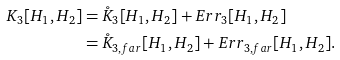Convert formula to latex. <formula><loc_0><loc_0><loc_500><loc_500>K _ { 3 } [ H _ { 1 } , H _ { 2 } ] & = \mathring { K } _ { 3 } [ H _ { 1 } , H _ { 2 } ] + E r r _ { 3 } [ H _ { 1 } , H _ { 2 } ] \\ & = \mathring { K } _ { 3 , f a r } [ H _ { 1 } , H _ { 2 } ] + E r r _ { 3 , f a r } [ H _ { 1 } , H _ { 2 } ] . \\</formula> 